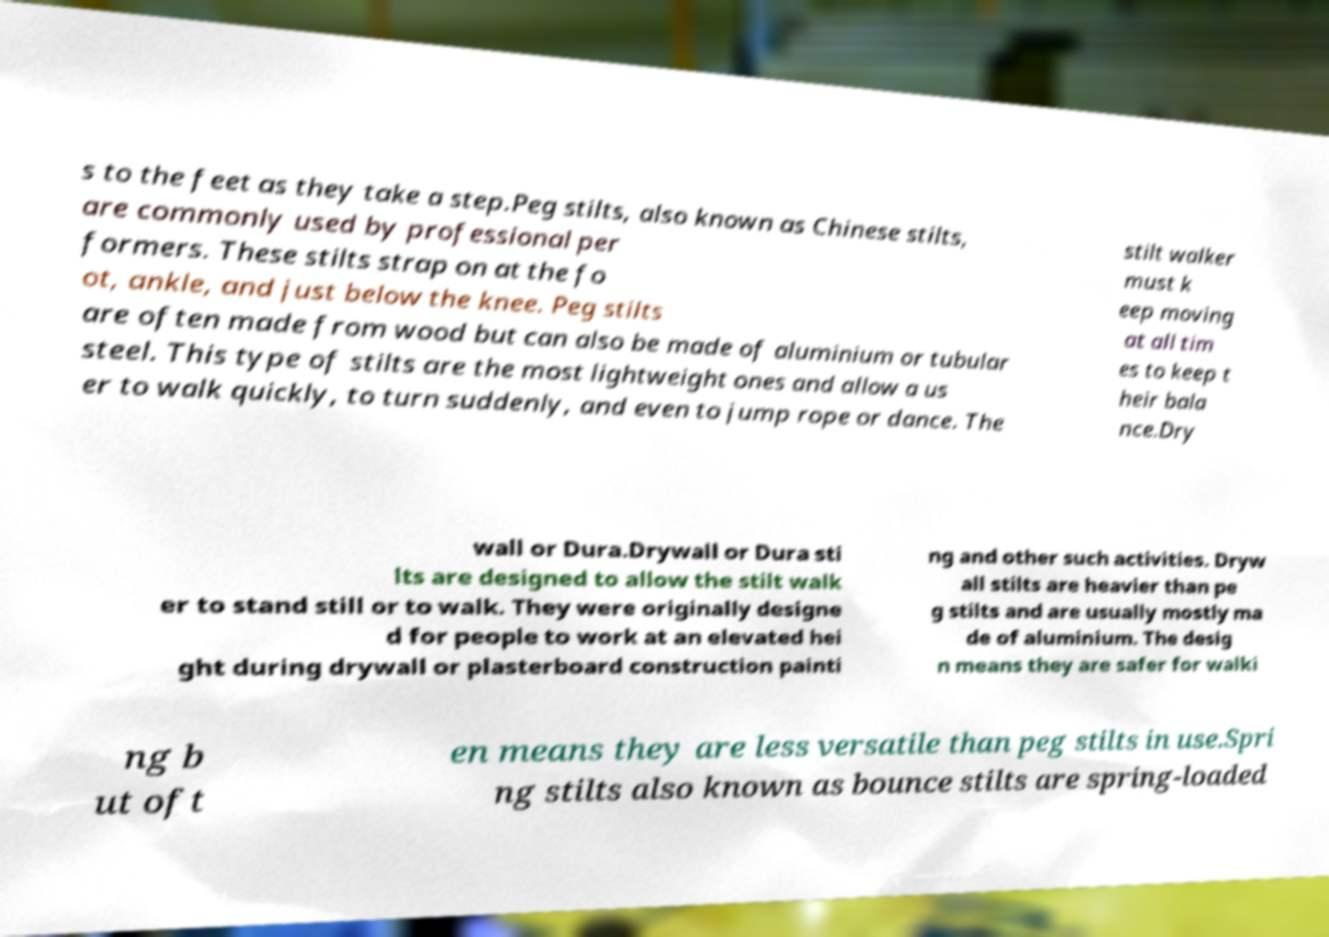Could you assist in decoding the text presented in this image and type it out clearly? s to the feet as they take a step.Peg stilts, also known as Chinese stilts, are commonly used by professional per formers. These stilts strap on at the fo ot, ankle, and just below the knee. Peg stilts are often made from wood but can also be made of aluminium or tubular steel. This type of stilts are the most lightweight ones and allow a us er to walk quickly, to turn suddenly, and even to jump rope or dance. The stilt walker must k eep moving at all tim es to keep t heir bala nce.Dry wall or Dura.Drywall or Dura sti lts are designed to allow the stilt walk er to stand still or to walk. They were originally designe d for people to work at an elevated hei ght during drywall or plasterboard construction painti ng and other such activities. Dryw all stilts are heavier than pe g stilts and are usually mostly ma de of aluminium. The desig n means they are safer for walki ng b ut oft en means they are less versatile than peg stilts in use.Spri ng stilts also known as bounce stilts are spring-loaded 